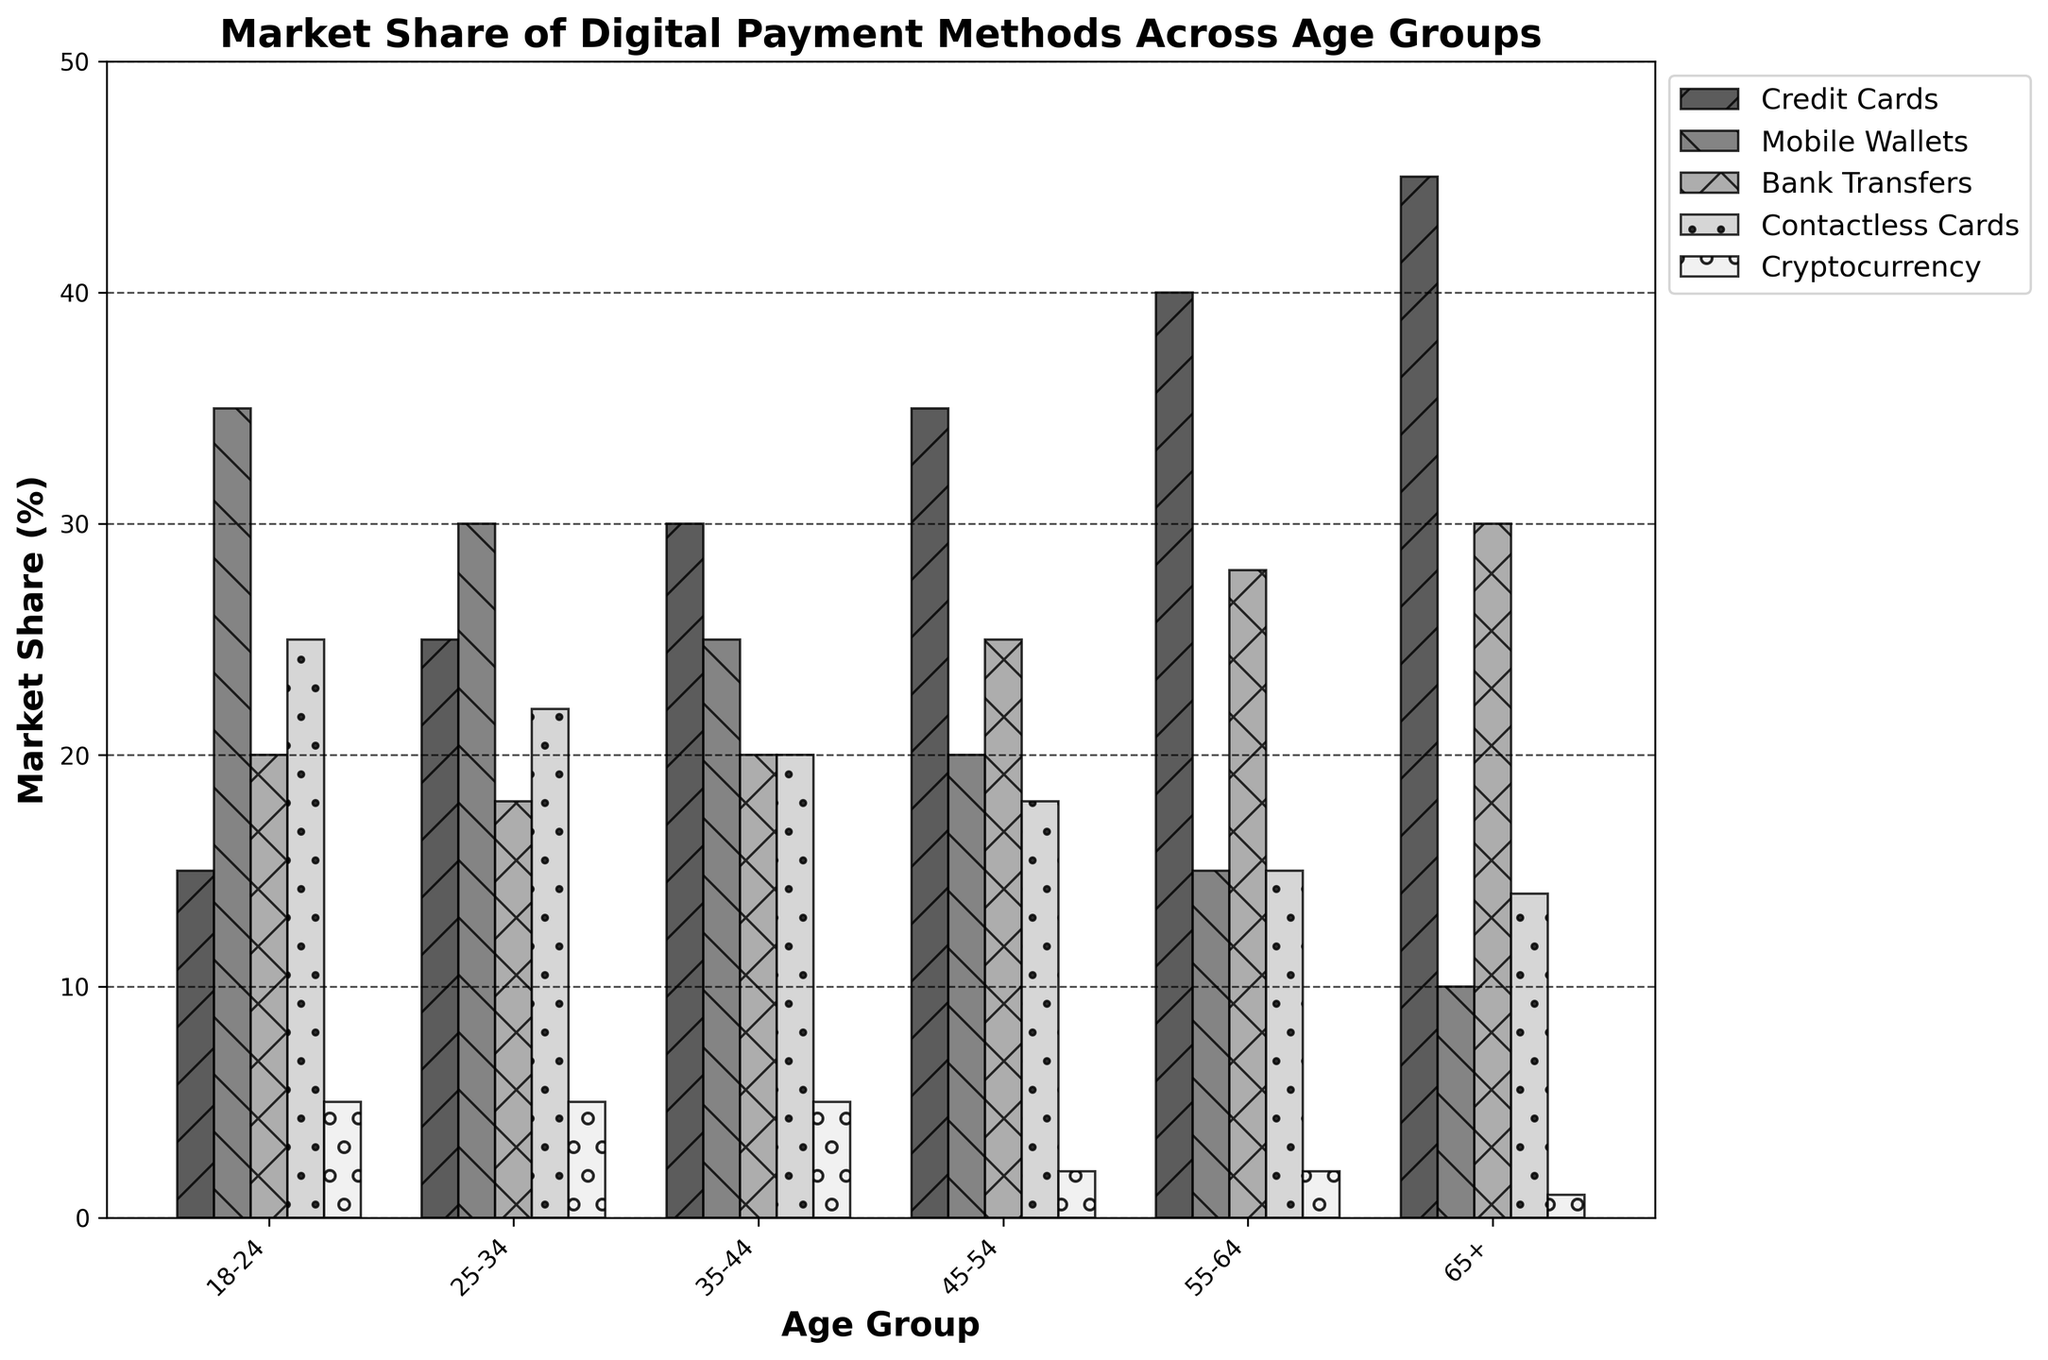What age group has the highest market share for Credit Cards? The highest market share for Credit Cards would be represented by the tallest bar in the Credit Cards category. By looking at the figure, the tallest bar for Credit Cards corresponds to the 65+ age group.
Answer: 65+ Which digital payment method is least popular among people aged 25-34? For the age group 25-34, the shortest bar would indicate the least popular payment method. In this case, the Cryptocurrency bar is the shortest, indicating it is the least popular.
Answer: Cryptocurrency How does the market share of Mobile Wallets compare between the 18-24 and 55-64 age groups? To compare market shares, observe the height of the Mobile Wallets bars for the two age groups. The Mobile Wallet market share for 18-24 is higher than for 55-64.
Answer: Higher for 18-24 What is the combined market share of Bank Transfers and Contactless Cards for the 45-54 age group? Add the market share percentages of Bank Transfers and Contactless Cards for the 45-54 age group. This is 25% (Bank Transfers) + 18% (Contactless Cards) = 43%.
Answer: 43% Among all age groups, which payment method has the most consistent market share? The most consistent market share will have bars of similar height across all age groups. Cryptocurrency bars are consistently low across all age groups (ranging from 1% to 5%).
Answer: Cryptocurrency What is the difference in market share between Credit Cards and Contactless Cards for the 35-44 age group? Find the market share percentages for Credit Cards and Contactless Cards in the 35-44 age group and subtract the Contactless Cards percentage from the Credit Cards percentage. This is 30% (Credit Cards) - 20% (Contactless Cards) = 10%.
Answer: 10% Which age group has the smallest usage of Contactless Cards? The age group with the shortest bar for Contactless Cards has the smallest usage. The bar for age group 65+ is the shortest for Contactless Cards at 14%.
Answer: 65+ What is the sum of market shares for Bank Transfers across all age groups? Sum the Bank Transfers market shares across all age groups: 20% (18-24) + 18% (25-34) + 20% (35-44) + 25% (45-54) + 28% (55-64) + 30% (65+). This totals to 141%.
Answer: 141% How does the market share of Cryptocurrencies change across different age groups? Observe the heights of the Cryptocurrency bars across all age groups. The market share decreases from younger to older age groups, starting at 5% for 18-24 and reducing to 1% for 65+.
Answer: Decreases gradually Which age group shows a significant preference for Credit Cards over Mobile Wallets, and what is the difference in their respective market shares? Look at the age group where the difference between the Credit Cards and Mobile Wallets bars is most significant. For the 65+ age group, Credit Cards have 45%, while Mobile Wallets have 10%. The difference is 45% - 10% = 35%.
Answer: 65+, 35% 